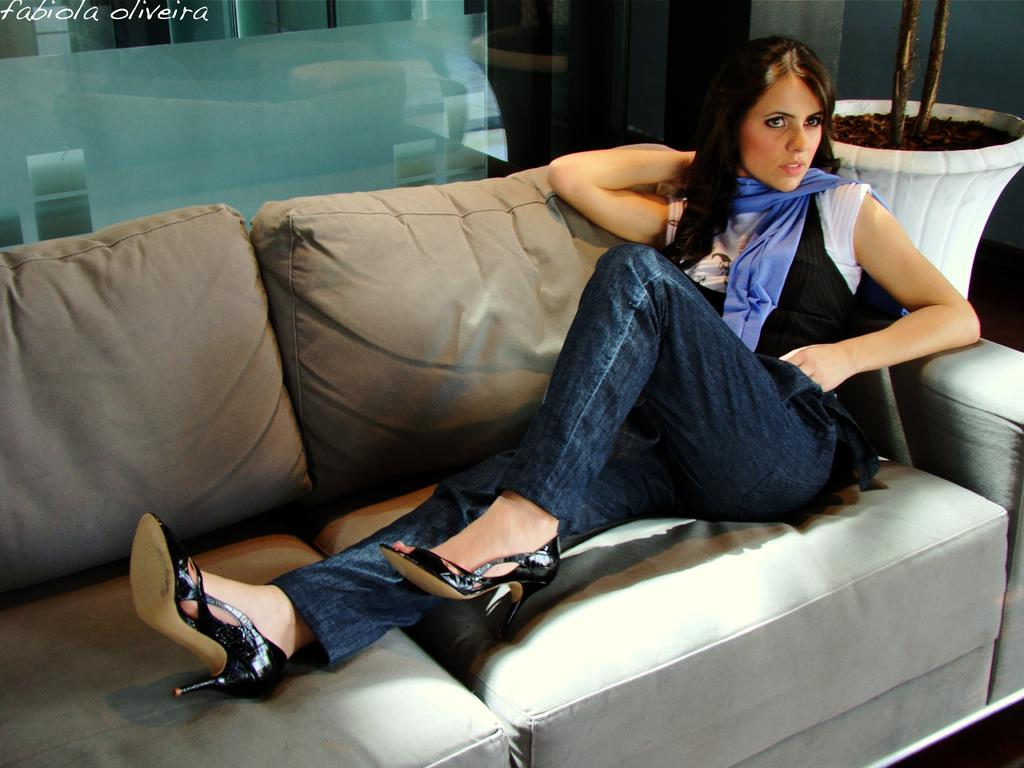What is the main subject of the image? The main subject of the image is a lady. Can you describe the lady's clothing? The lady is wearing a black and white shirt and blue jeans. What type of footwear is the lady wearing? The lady is wearing black footwear. Where is the lady sitting in the image? The lady is sitting on a sofa. What else can be seen on the sofa? There is a plant on the sofa. What is visible behind the lady? There is a glass wall behind the lady. What type of insurance policy does the kitty have in the image? There is no kitty present in the image, and therefore no insurance policy can be discussed. What type of office furniture can be seen in the image? The image does not depict an office setting, so there is no office furniture present. 